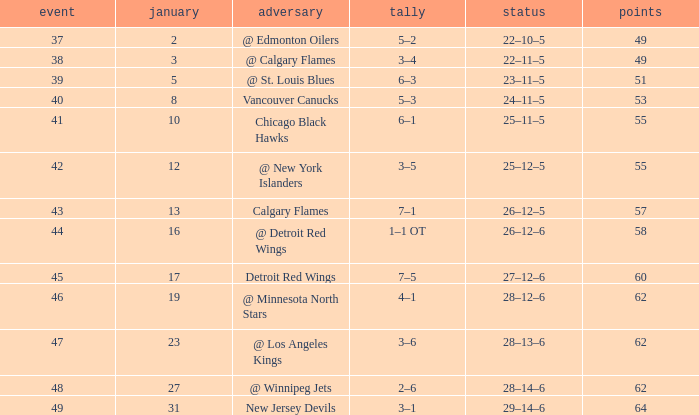Which Points have a Score of 4–1? 62.0. 